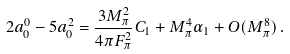Convert formula to latex. <formula><loc_0><loc_0><loc_500><loc_500>2 a _ { 0 } ^ { 0 } - 5 a _ { 0 } ^ { 2 } = \frac { 3 M _ { \pi } ^ { 2 } } { 4 \pi F _ { \pi } ^ { 2 } } C _ { 1 } + M _ { \pi } ^ { 4 } \alpha _ { 1 } + O ( M _ { \pi } ^ { 8 } ) \, .</formula> 